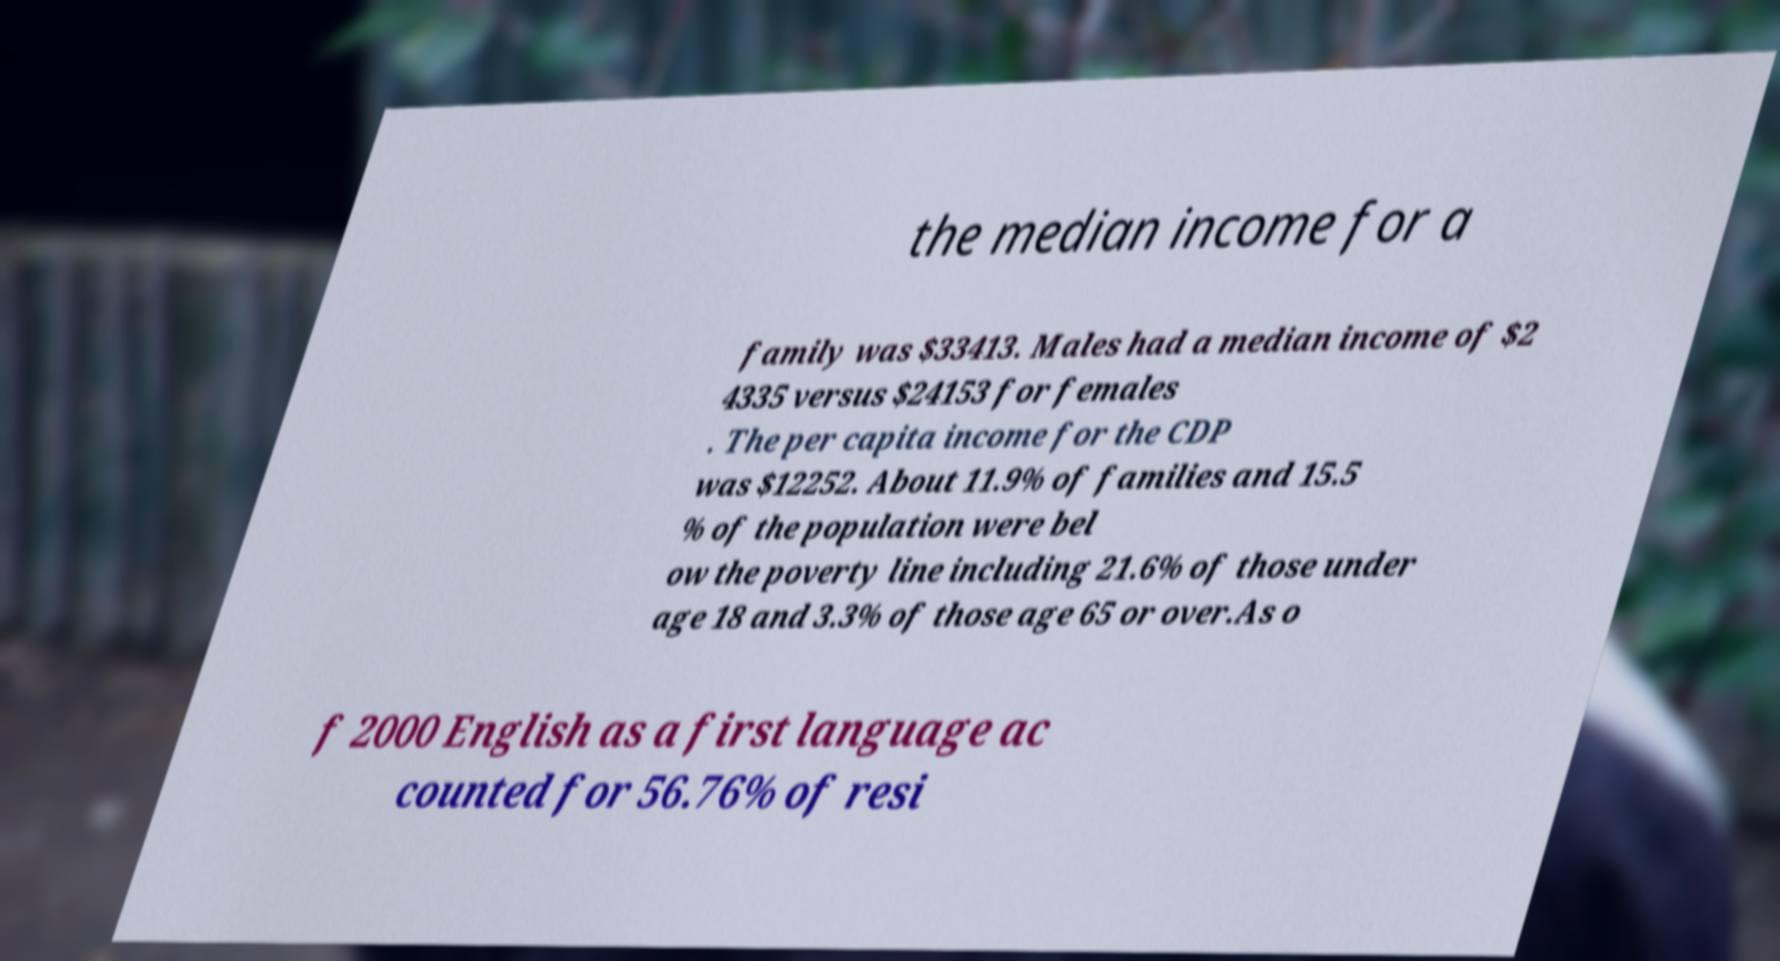For documentation purposes, I need the text within this image transcribed. Could you provide that? the median income for a family was $33413. Males had a median income of $2 4335 versus $24153 for females . The per capita income for the CDP was $12252. About 11.9% of families and 15.5 % of the population were bel ow the poverty line including 21.6% of those under age 18 and 3.3% of those age 65 or over.As o f 2000 English as a first language ac counted for 56.76% of resi 